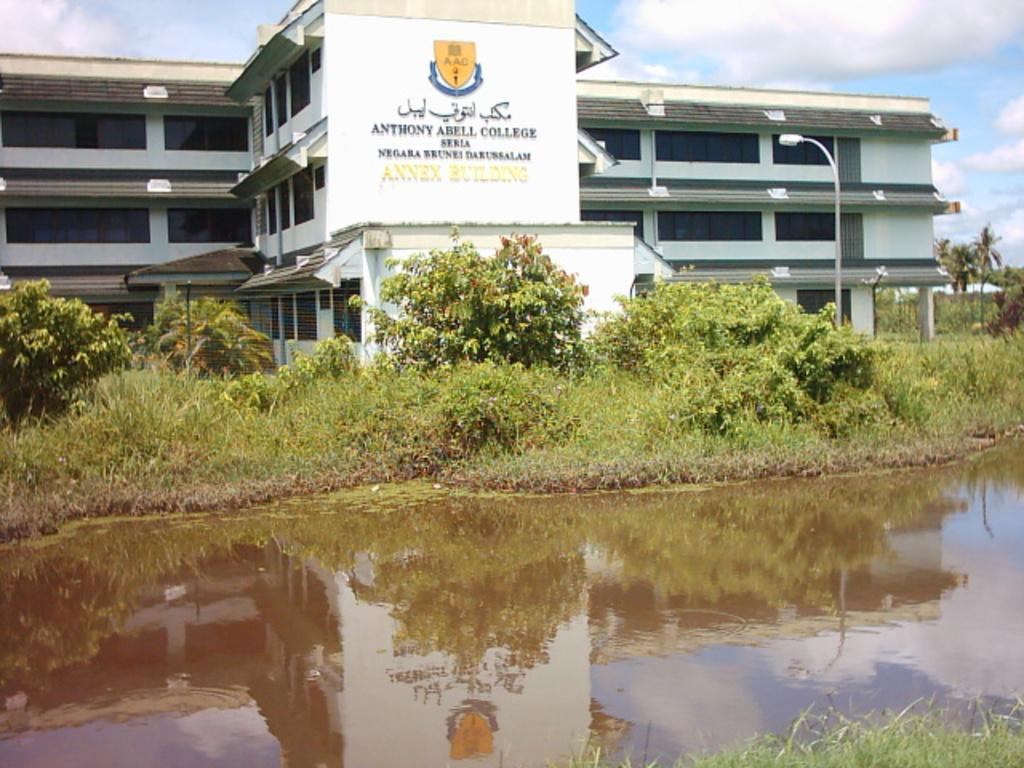<image>
Provide a brief description of the given image. Anthony Abell College is the building  along the body of water in the picture. 